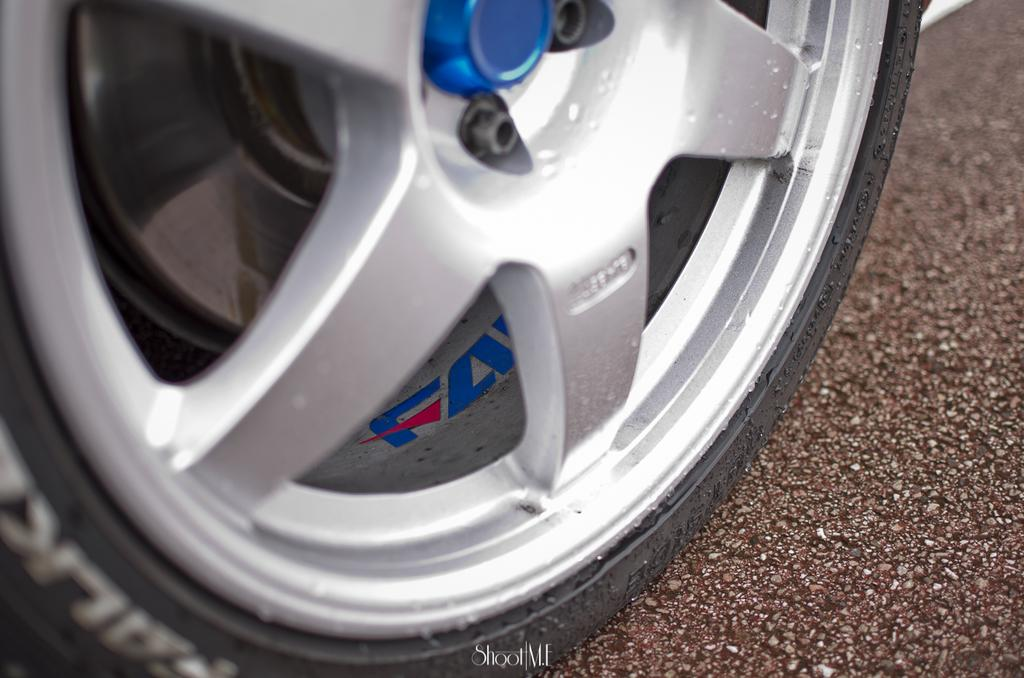What is the main subject of the image? The main subject of the image is a wheel of a car. Can you describe the time of day when the image was taken? The image was taken during the day. What type of cheese can be seen in the store in the image? There is no store or cheese present in the image; it only features a wheel of a car. 